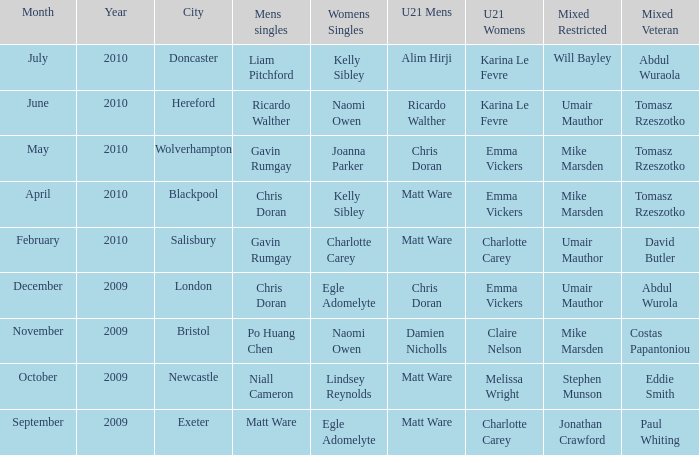Who was the U21 Mens winner when Mike Marsden was the mixed restricted winner and Claire Nelson was the U21 Womens winner?  Damien Nicholls. 